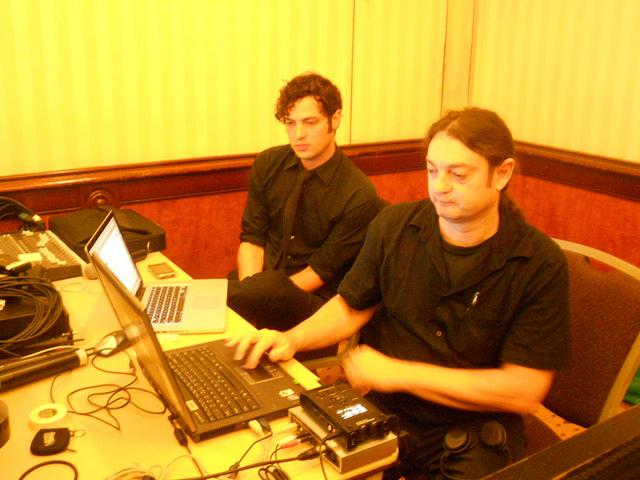Why is he looking at the other guy's laptop? Please explain your reasoning. is learning. The guy seems to be taught something by the way he looks. 